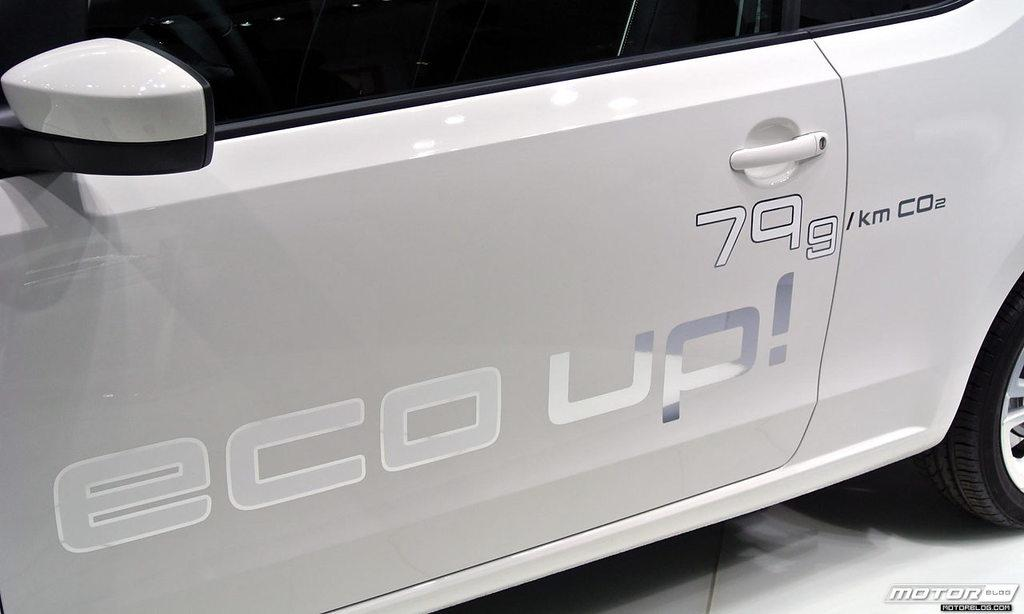What object in the image reflects light? There is a mirror in the image that reflects light. What type of vehicle is partially visible in the image? There is a door of a white-colored vehicle in the image. What can be seen written or printed in the image? Something is written in the image. What part of the vehicle can be seen in the image? There is a wheel of the vehicle visible in the image. How many trees are visible in the image? There are no trees visible in the image. What type of waste is being disposed of in the image? There is no waste being disposed of in the image. 